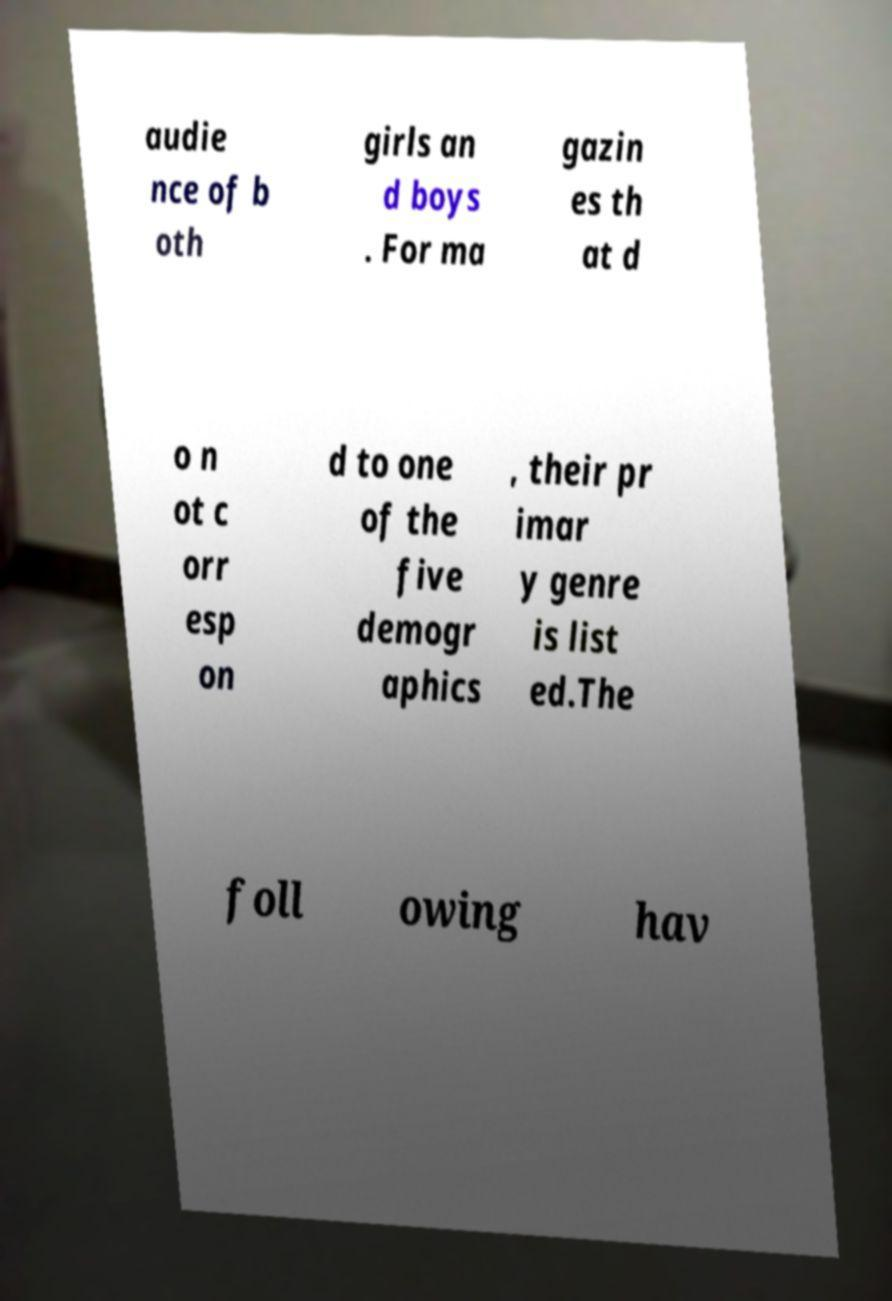For documentation purposes, I need the text within this image transcribed. Could you provide that? audie nce of b oth girls an d boys . For ma gazin es th at d o n ot c orr esp on d to one of the five demogr aphics , their pr imar y genre is list ed.The foll owing hav 